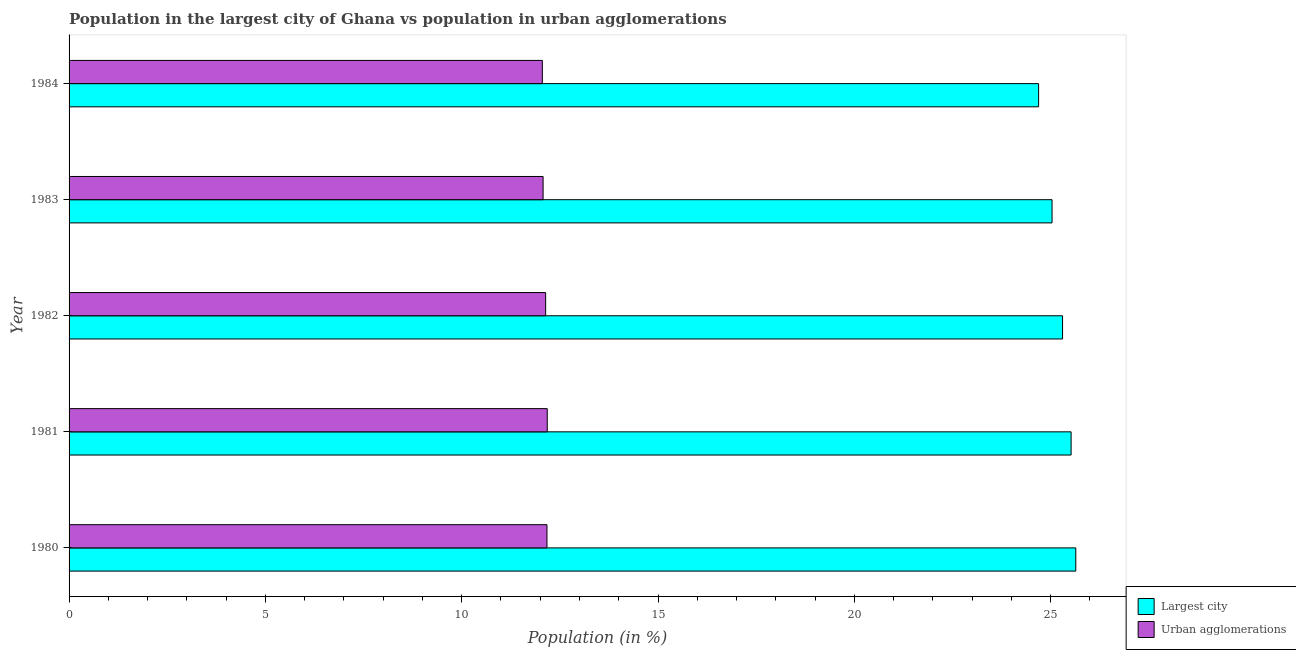How many groups of bars are there?
Your response must be concise. 5. Are the number of bars on each tick of the Y-axis equal?
Your response must be concise. Yes. How many bars are there on the 2nd tick from the top?
Your answer should be very brief. 2. How many bars are there on the 2nd tick from the bottom?
Your answer should be very brief. 2. What is the label of the 5th group of bars from the top?
Provide a short and direct response. 1980. In how many cases, is the number of bars for a given year not equal to the number of legend labels?
Your answer should be compact. 0. What is the population in urban agglomerations in 1980?
Give a very brief answer. 12.17. Across all years, what is the maximum population in the largest city?
Ensure brevity in your answer.  25.64. Across all years, what is the minimum population in urban agglomerations?
Give a very brief answer. 12.05. What is the total population in urban agglomerations in the graph?
Provide a short and direct response. 60.62. What is the difference between the population in the largest city in 1981 and that in 1984?
Provide a succinct answer. 0.83. What is the difference between the population in urban agglomerations in 1981 and the population in the largest city in 1982?
Give a very brief answer. -13.12. What is the average population in the largest city per year?
Provide a short and direct response. 25.24. In the year 1983, what is the difference between the population in urban agglomerations and population in the largest city?
Give a very brief answer. -12.96. In how many years, is the population in the largest city greater than 19 %?
Offer a terse response. 5. Is the difference between the population in urban agglomerations in 1980 and 1982 greater than the difference between the population in the largest city in 1980 and 1982?
Your response must be concise. No. What is the difference between the highest and the second highest population in urban agglomerations?
Ensure brevity in your answer.  0.01. What is the difference between the highest and the lowest population in urban agglomerations?
Offer a terse response. 0.12. Is the sum of the population in urban agglomerations in 1981 and 1984 greater than the maximum population in the largest city across all years?
Your answer should be very brief. No. What does the 1st bar from the top in 1983 represents?
Offer a terse response. Urban agglomerations. What does the 1st bar from the bottom in 1981 represents?
Keep it short and to the point. Largest city. How many years are there in the graph?
Provide a succinct answer. 5. Are the values on the major ticks of X-axis written in scientific E-notation?
Your answer should be compact. No. Does the graph contain any zero values?
Provide a short and direct response. No. Does the graph contain grids?
Provide a short and direct response. No. How many legend labels are there?
Offer a terse response. 2. What is the title of the graph?
Ensure brevity in your answer.  Population in the largest city of Ghana vs population in urban agglomerations. What is the label or title of the X-axis?
Offer a terse response. Population (in %). What is the Population (in %) of Largest city in 1980?
Your response must be concise. 25.64. What is the Population (in %) of Urban agglomerations in 1980?
Offer a very short reply. 12.17. What is the Population (in %) in Largest city in 1981?
Your response must be concise. 25.52. What is the Population (in %) in Urban agglomerations in 1981?
Give a very brief answer. 12.18. What is the Population (in %) in Largest city in 1982?
Your response must be concise. 25.3. What is the Population (in %) in Urban agglomerations in 1982?
Give a very brief answer. 12.14. What is the Population (in %) of Largest city in 1983?
Provide a succinct answer. 25.04. What is the Population (in %) of Urban agglomerations in 1983?
Your response must be concise. 12.07. What is the Population (in %) in Largest city in 1984?
Make the answer very short. 24.69. What is the Population (in %) in Urban agglomerations in 1984?
Your response must be concise. 12.05. Across all years, what is the maximum Population (in %) of Largest city?
Give a very brief answer. 25.64. Across all years, what is the maximum Population (in %) of Urban agglomerations?
Your response must be concise. 12.18. Across all years, what is the minimum Population (in %) of Largest city?
Your response must be concise. 24.69. Across all years, what is the minimum Population (in %) in Urban agglomerations?
Offer a terse response. 12.05. What is the total Population (in %) of Largest city in the graph?
Make the answer very short. 126.2. What is the total Population (in %) in Urban agglomerations in the graph?
Offer a very short reply. 60.62. What is the difference between the Population (in %) of Largest city in 1980 and that in 1981?
Your answer should be very brief. 0.12. What is the difference between the Population (in %) of Urban agglomerations in 1980 and that in 1981?
Make the answer very short. -0.01. What is the difference between the Population (in %) in Largest city in 1980 and that in 1982?
Your response must be concise. 0.34. What is the difference between the Population (in %) of Urban agglomerations in 1980 and that in 1982?
Your answer should be compact. 0.03. What is the difference between the Population (in %) of Largest city in 1980 and that in 1983?
Offer a very short reply. 0.6. What is the difference between the Population (in %) in Urban agglomerations in 1980 and that in 1983?
Keep it short and to the point. 0.1. What is the difference between the Population (in %) of Largest city in 1980 and that in 1984?
Make the answer very short. 0.95. What is the difference between the Population (in %) of Urban agglomerations in 1980 and that in 1984?
Your answer should be very brief. 0.12. What is the difference between the Population (in %) of Largest city in 1981 and that in 1982?
Make the answer very short. 0.22. What is the difference between the Population (in %) in Urban agglomerations in 1981 and that in 1982?
Make the answer very short. 0.04. What is the difference between the Population (in %) in Largest city in 1981 and that in 1983?
Provide a short and direct response. 0.49. What is the difference between the Population (in %) in Urban agglomerations in 1981 and that in 1983?
Provide a succinct answer. 0.11. What is the difference between the Population (in %) of Largest city in 1981 and that in 1984?
Ensure brevity in your answer.  0.83. What is the difference between the Population (in %) of Urban agglomerations in 1981 and that in 1984?
Provide a short and direct response. 0.12. What is the difference between the Population (in %) of Largest city in 1982 and that in 1983?
Ensure brevity in your answer.  0.27. What is the difference between the Population (in %) in Urban agglomerations in 1982 and that in 1983?
Keep it short and to the point. 0.07. What is the difference between the Population (in %) of Largest city in 1982 and that in 1984?
Your response must be concise. 0.61. What is the difference between the Population (in %) in Urban agglomerations in 1982 and that in 1984?
Give a very brief answer. 0.08. What is the difference between the Population (in %) in Largest city in 1983 and that in 1984?
Keep it short and to the point. 0.34. What is the difference between the Population (in %) of Urban agglomerations in 1983 and that in 1984?
Keep it short and to the point. 0.02. What is the difference between the Population (in %) of Largest city in 1980 and the Population (in %) of Urban agglomerations in 1981?
Give a very brief answer. 13.46. What is the difference between the Population (in %) in Largest city in 1980 and the Population (in %) in Urban agglomerations in 1982?
Provide a succinct answer. 13.5. What is the difference between the Population (in %) of Largest city in 1980 and the Population (in %) of Urban agglomerations in 1983?
Keep it short and to the point. 13.57. What is the difference between the Population (in %) of Largest city in 1980 and the Population (in %) of Urban agglomerations in 1984?
Make the answer very short. 13.59. What is the difference between the Population (in %) in Largest city in 1981 and the Population (in %) in Urban agglomerations in 1982?
Your answer should be very brief. 13.38. What is the difference between the Population (in %) of Largest city in 1981 and the Population (in %) of Urban agglomerations in 1983?
Your response must be concise. 13.45. What is the difference between the Population (in %) in Largest city in 1981 and the Population (in %) in Urban agglomerations in 1984?
Make the answer very short. 13.47. What is the difference between the Population (in %) of Largest city in 1982 and the Population (in %) of Urban agglomerations in 1983?
Provide a short and direct response. 13.23. What is the difference between the Population (in %) of Largest city in 1982 and the Population (in %) of Urban agglomerations in 1984?
Provide a succinct answer. 13.25. What is the difference between the Population (in %) of Largest city in 1983 and the Population (in %) of Urban agglomerations in 1984?
Provide a short and direct response. 12.98. What is the average Population (in %) in Largest city per year?
Your response must be concise. 25.24. What is the average Population (in %) of Urban agglomerations per year?
Make the answer very short. 12.12. In the year 1980, what is the difference between the Population (in %) of Largest city and Population (in %) of Urban agglomerations?
Give a very brief answer. 13.47. In the year 1981, what is the difference between the Population (in %) of Largest city and Population (in %) of Urban agglomerations?
Provide a succinct answer. 13.34. In the year 1982, what is the difference between the Population (in %) of Largest city and Population (in %) of Urban agglomerations?
Offer a very short reply. 13.17. In the year 1983, what is the difference between the Population (in %) of Largest city and Population (in %) of Urban agglomerations?
Make the answer very short. 12.96. In the year 1984, what is the difference between the Population (in %) in Largest city and Population (in %) in Urban agglomerations?
Offer a terse response. 12.64. What is the ratio of the Population (in %) in Largest city in 1980 to that in 1982?
Keep it short and to the point. 1.01. What is the ratio of the Population (in %) in Urban agglomerations in 1980 to that in 1982?
Ensure brevity in your answer.  1. What is the ratio of the Population (in %) of Largest city in 1980 to that in 1983?
Ensure brevity in your answer.  1.02. What is the ratio of the Population (in %) in Urban agglomerations in 1980 to that in 1983?
Provide a short and direct response. 1.01. What is the ratio of the Population (in %) of Largest city in 1980 to that in 1984?
Offer a terse response. 1.04. What is the ratio of the Population (in %) of Urban agglomerations in 1980 to that in 1984?
Your answer should be very brief. 1.01. What is the ratio of the Population (in %) in Largest city in 1981 to that in 1982?
Provide a short and direct response. 1.01. What is the ratio of the Population (in %) of Largest city in 1981 to that in 1983?
Make the answer very short. 1.02. What is the ratio of the Population (in %) in Urban agglomerations in 1981 to that in 1983?
Your response must be concise. 1.01. What is the ratio of the Population (in %) of Largest city in 1981 to that in 1984?
Your answer should be very brief. 1.03. What is the ratio of the Population (in %) of Urban agglomerations in 1981 to that in 1984?
Provide a short and direct response. 1.01. What is the ratio of the Population (in %) of Largest city in 1982 to that in 1983?
Provide a short and direct response. 1.01. What is the ratio of the Population (in %) of Urban agglomerations in 1982 to that in 1983?
Provide a short and direct response. 1.01. What is the ratio of the Population (in %) of Largest city in 1982 to that in 1984?
Your response must be concise. 1.02. What is the ratio of the Population (in %) of Urban agglomerations in 1982 to that in 1984?
Give a very brief answer. 1.01. What is the ratio of the Population (in %) of Largest city in 1983 to that in 1984?
Your answer should be very brief. 1.01. What is the difference between the highest and the second highest Population (in %) of Largest city?
Keep it short and to the point. 0.12. What is the difference between the highest and the second highest Population (in %) of Urban agglomerations?
Provide a short and direct response. 0.01. What is the difference between the highest and the lowest Population (in %) of Largest city?
Ensure brevity in your answer.  0.95. What is the difference between the highest and the lowest Population (in %) in Urban agglomerations?
Your response must be concise. 0.12. 